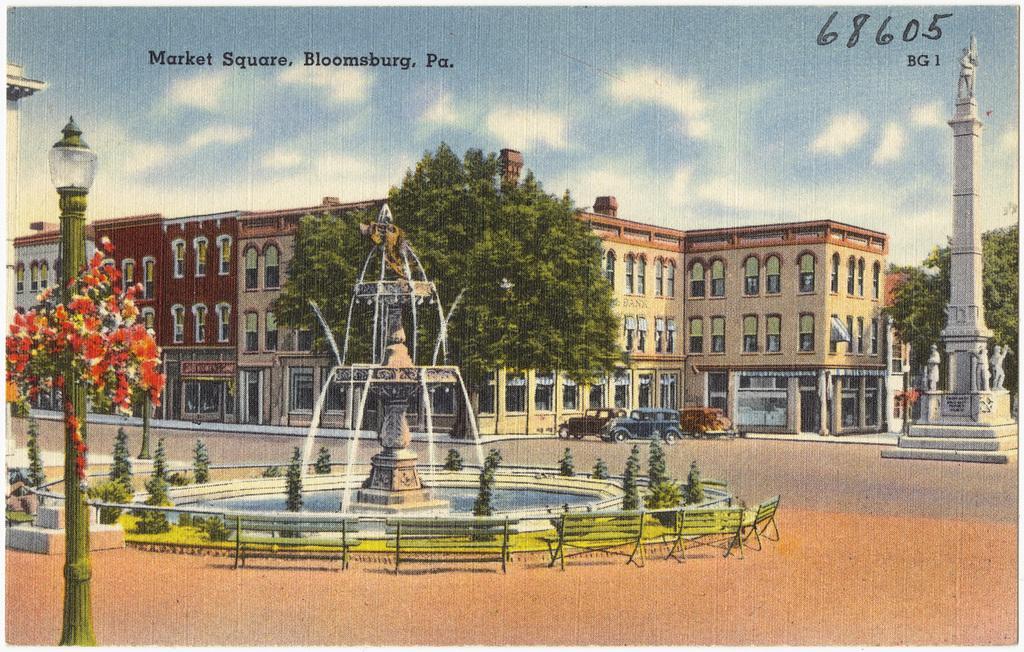Could you give a brief overview of what you see in this image? In the image there is a painting of building in the back with trees and cars in front of it, there is a statue on the right side and water fall in the middle and above its sky with clouds. 